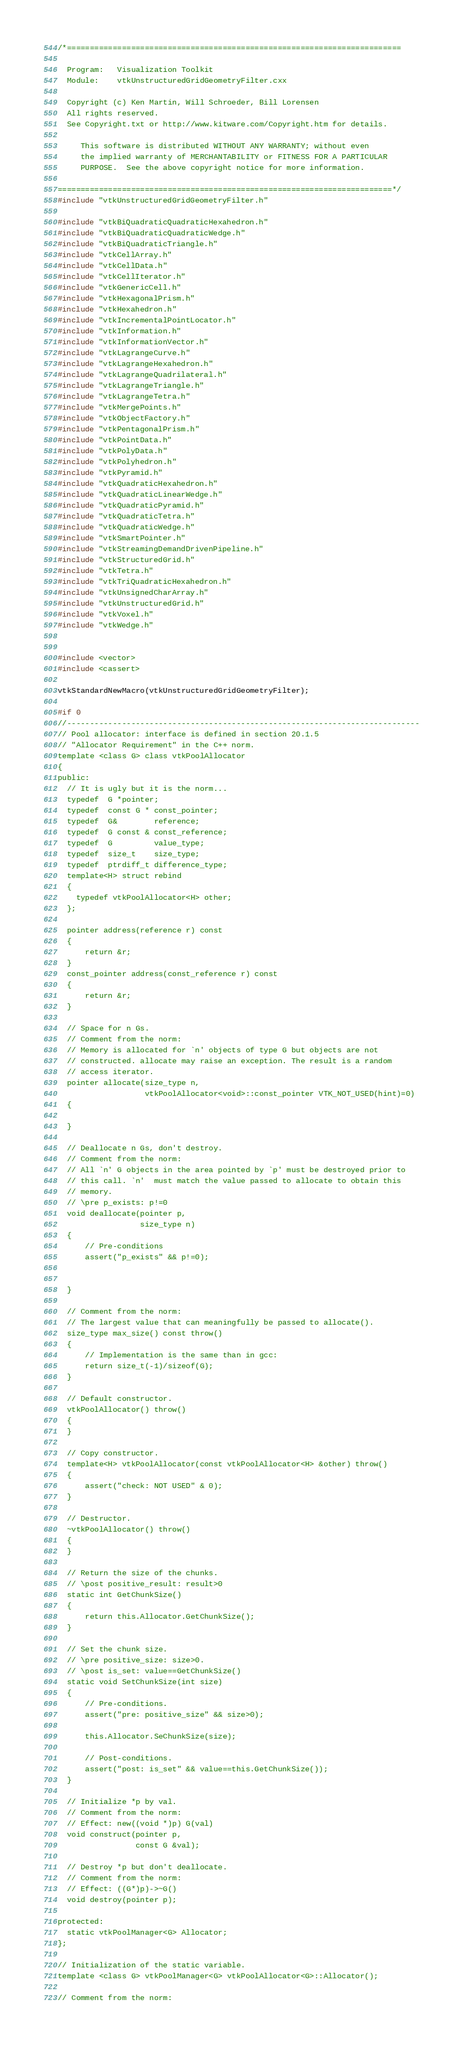<code> <loc_0><loc_0><loc_500><loc_500><_C++_>/*=========================================================================

  Program:   Visualization Toolkit
  Module:    vtkUnstructuredGridGeometryFilter.cxx

  Copyright (c) Ken Martin, Will Schroeder, Bill Lorensen
  All rights reserved.
  See Copyright.txt or http://www.kitware.com/Copyright.htm for details.

     This software is distributed WITHOUT ANY WARRANTY; without even
     the implied warranty of MERCHANTABILITY or FITNESS FOR A PARTICULAR
     PURPOSE.  See the above copyright notice for more information.

=========================================================================*/
#include "vtkUnstructuredGridGeometryFilter.h"

#include "vtkBiQuadraticQuadraticHexahedron.h"
#include "vtkBiQuadraticQuadraticWedge.h"
#include "vtkBiQuadraticTriangle.h"
#include "vtkCellArray.h"
#include "vtkCellData.h"
#include "vtkCellIterator.h"
#include "vtkGenericCell.h"
#include "vtkHexagonalPrism.h"
#include "vtkHexahedron.h"
#include "vtkIncrementalPointLocator.h"
#include "vtkInformation.h"
#include "vtkInformationVector.h"
#include "vtkLagrangeCurve.h"
#include "vtkLagrangeHexahedron.h"
#include "vtkLagrangeQuadrilateral.h"
#include "vtkLagrangeTriangle.h"
#include "vtkLagrangeTetra.h"
#include "vtkMergePoints.h"
#include "vtkObjectFactory.h"
#include "vtkPentagonalPrism.h"
#include "vtkPointData.h"
#include "vtkPolyData.h"
#include "vtkPolyhedron.h"
#include "vtkPyramid.h"
#include "vtkQuadraticHexahedron.h"
#include "vtkQuadraticLinearWedge.h"
#include "vtkQuadraticPyramid.h"
#include "vtkQuadraticTetra.h"
#include "vtkQuadraticWedge.h"
#include "vtkSmartPointer.h"
#include "vtkStreamingDemandDrivenPipeline.h"
#include "vtkStructuredGrid.h"
#include "vtkTetra.h"
#include "vtkTriQuadraticHexahedron.h"
#include "vtkUnsignedCharArray.h"
#include "vtkUnstructuredGrid.h"
#include "vtkVoxel.h"
#include "vtkWedge.h"


#include <vector>
#include <cassert>

vtkStandardNewMacro(vtkUnstructuredGridGeometryFilter);

#if 0
//-----------------------------------------------------------------------------
// Pool allocator: interface is defined in section 20.1.5
// "Allocator Requirement" in the C++ norm.
template <class G> class vtkPoolAllocator
{
public:
  // It is ugly but it is the norm...
  typedef  G *pointer;
  typedef  const G * const_pointer;
  typedef  G&        reference;
  typedef  G const & const_reference;
  typedef  G         value_type;
  typedef  size_t    size_type;
  typedef  ptrdiff_t difference_type;
  template<H> struct rebind
  {
    typedef vtkPoolAllocator<H> other;
  };

  pointer address(reference r) const
  {
      return &r;
  }
  const_pointer address(const_reference r) const
  {
      return &r;
  }

  // Space for n Gs.
  // Comment from the norm:
  // Memory is allocated for `n' objects of type G but objects are not
  // constructed. allocate may raise an exception. The result is a random
  // access iterator.
  pointer allocate(size_type n,
                   vtkPoolAllocator<void>::const_pointer VTK_NOT_USED(hint)=0)
  {

  }

  // Deallocate n Gs, don't destroy.
  // Comment from the norm:
  // All `n' G objects in the area pointed by `p' must be destroyed prior to
  // this call. `n'  must match the value passed to allocate to obtain this
  // memory.
  // \pre p_exists: p!=0
  void deallocate(pointer p,
                  size_type n)
  {
      // Pre-conditions
      assert("p_exists" && p!=0);


  }

  // Comment from the norm:
  // The largest value that can meaningfully be passed to allocate().
  size_type max_size() const throw()
  {
      // Implementation is the same than in gcc:
      return size_t(-1)/sizeof(G);
  }

  // Default constructor.
  vtkPoolAllocator() throw()
  {
  }

  // Copy constructor.
  template<H> vtkPoolAllocator(const vtkPoolAllocator<H> &other) throw()
  {
      assert("check: NOT USED" & 0);
  }

  // Destructor.
  ~vtkPoolAllocator() throw()
  {
  }

  // Return the size of the chunks.
  // \post positive_result: result>0
  static int GetChunkSize()
  {
      return this.Allocator.GetChunkSize();
  }

  // Set the chunk size.
  // \pre positive_size: size>0.
  // \post is_set: value==GetChunkSize()
  static void SetChunkSize(int size)
  {
      // Pre-conditions.
      assert("pre: positive_size" && size>0);

      this.Allocator.SeChunkSize(size);

      // Post-conditions.
      assert("post: is_set" && value==this.GetChunkSize());
  }

  // Initialize *p by val.
  // Comment from the norm:
  // Effect: new((void *)p) G(val)
  void construct(pointer p,
                 const G &val);

  // Destroy *p but don't deallocate.
  // Comment from the norm:
  // Effect: ((G*)p)->~G()
  void destroy(pointer p);

protected:
  static vtkPoolManager<G> Allocator;
};

// Initialization of the static variable.
template <class G> vtkPoolManager<G> vtkPoolAllocator<G>::Allocator();

// Comment from the norm:</code> 